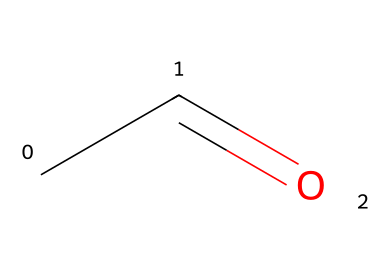What is the name of this chemical? The SMILES representation CC=O corresponds to acetaldehyde, which is a common name for the chemical compound with this structure.
Answer: acetaldehyde How many carbon atoms are in this molecule? The SMILES representation CC=O indicates there are two carbon atoms in the structure, as "CC" indicates two carbons.
Answer: 2 What is the functional group present in acetaldehyde? The presence of the carbonyl group (C=O) in the structure indicates that this compound is an aldehyde, which is defined by having a carbonyl group at the end of the carbon chain.
Answer: aldehyde How many hydrogen atoms are attached to the carbon in the aldehyde group? In the structure CC=O, the carbonyl (C=O) carbon is attached to one hydrogen atom because of the aldehyde structure, leading to a total of one relevant hydrogen atom.
Answer: 1 What type of chemical bond connects the carbon atom to the oxygen atom? In the chemical structure CC=O, the bond between the carbon atom and the oxygen atom is a double bond, as indicated by the "=" sign in the SMILES notation.
Answer: double bond Which process produces acetaldehyde in the body? Acetaldehyde is produced during the metabolism of ethanol (alcohol), as it is an intermediate compound formed in this biochemical process.
Answer: metabolism of ethanol 